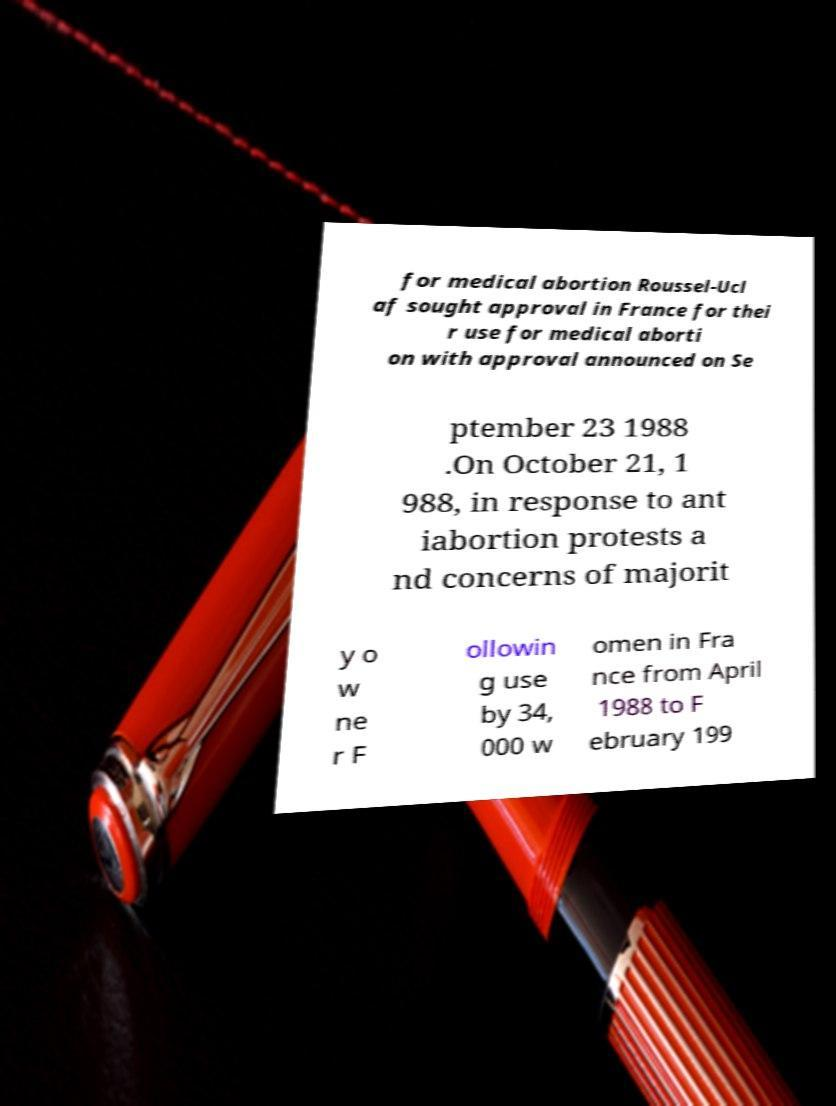What messages or text are displayed in this image? I need them in a readable, typed format. for medical abortion Roussel-Ucl af sought approval in France for thei r use for medical aborti on with approval announced on Se ptember 23 1988 .On October 21, 1 988, in response to ant iabortion protests a nd concerns of majorit y o w ne r F ollowin g use by 34, 000 w omen in Fra nce from April 1988 to F ebruary 199 